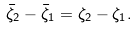Convert formula to latex. <formula><loc_0><loc_0><loc_500><loc_500>\bar { \zeta } _ { 2 } - \bar { \zeta } _ { 1 } = \zeta _ { 2 } - \zeta _ { 1 } .</formula> 